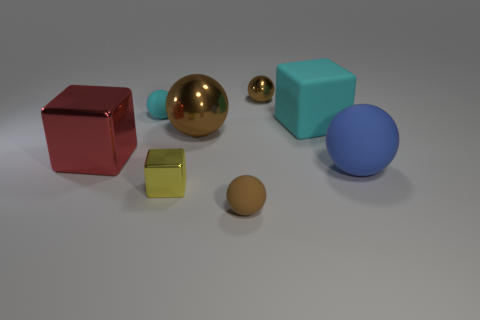Are there more blue balls that are behind the large red metallic thing than tiny gray shiny balls?
Provide a short and direct response. No. How many other objects are the same shape as the big cyan thing?
Offer a terse response. 2. There is a tiny object that is to the right of the small yellow metal thing and in front of the big blue matte ball; what material is it?
Provide a succinct answer. Rubber. How many things are blue balls or small yellow things?
Offer a very short reply. 2. Are there more red shiny cylinders than big blue matte balls?
Your answer should be compact. No. There is a brown metallic ball in front of the matte object on the left side of the big brown sphere; what size is it?
Your answer should be compact. Large. What is the color of the big matte thing that is the same shape as the small brown rubber thing?
Offer a very short reply. Blue. How big is the yellow thing?
Make the answer very short. Small. How many cylinders are either small shiny things or blue objects?
Provide a short and direct response. 0. What is the size of the cyan matte thing that is the same shape as the small brown matte thing?
Your response must be concise. Small. 